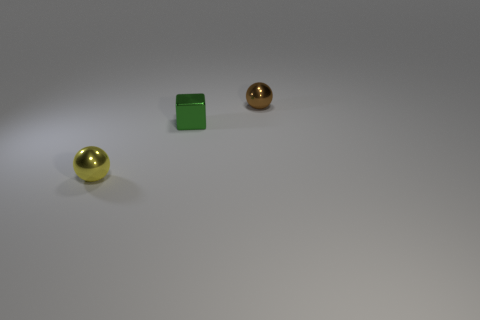Add 3 yellow spheres. How many objects exist? 6 Subtract all blocks. How many objects are left? 2 Add 2 brown balls. How many brown balls are left? 3 Add 3 shiny blocks. How many shiny blocks exist? 4 Subtract 1 yellow spheres. How many objects are left? 2 Subtract all tiny cyan rubber cylinders. Subtract all green shiny blocks. How many objects are left? 2 